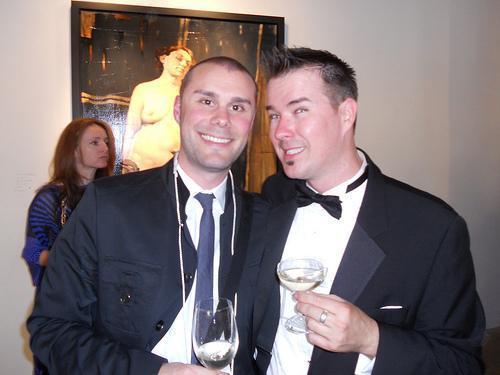How many people are in the photo?
Give a very brief answer. 3. How many men are in the photo?
Give a very brief answer. 2. 